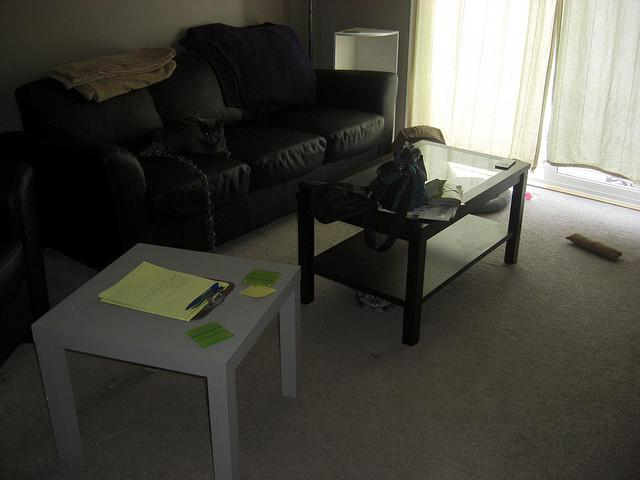What color has two post-its? Please explain your reasoning. green. You can tell by the color and size of the paper as to what the color is for the post-its. 